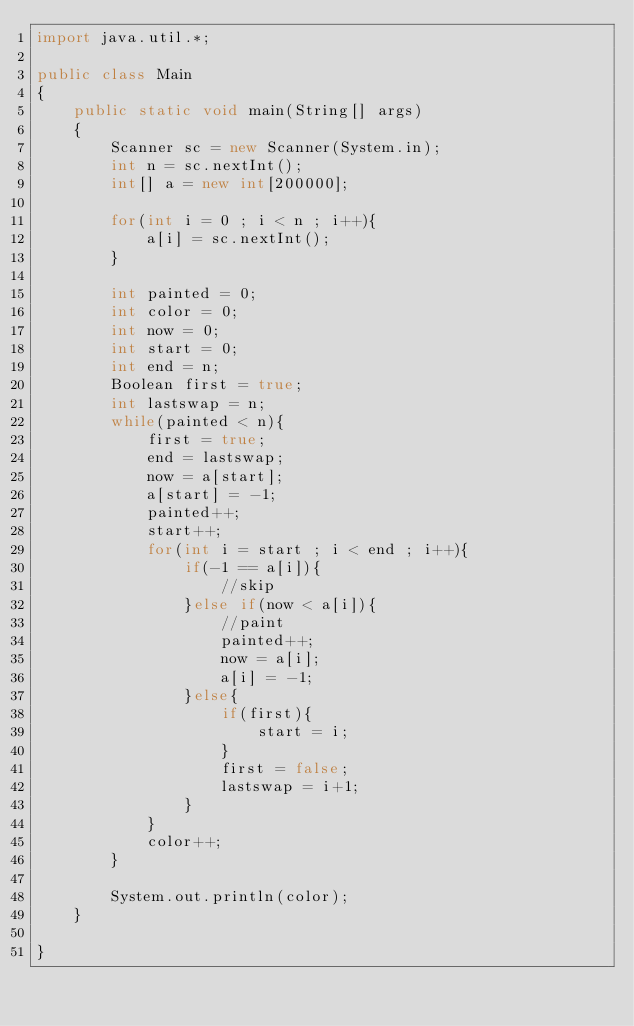<code> <loc_0><loc_0><loc_500><loc_500><_Java_>import java.util.*;

public class Main
{
	public static void main(String[] args)
	{
		Scanner sc = new Scanner(System.in);
		int n = sc.nextInt();
		int[] a = new int[200000];

		for(int i = 0 ; i < n ; i++){
			a[i] = sc.nextInt();
		}

		int painted = 0;
		int color = 0;
		int now = 0;
		int start = 0;
		int end = n;
		Boolean first = true;
		int lastswap = n;
		while(painted < n){
			first = true;
			end = lastswap;
			now = a[start];
			a[start] = -1;
			painted++;
			start++;
			for(int i = start ; i < end ; i++){
				if(-1 == a[i]){
					//skip
				}else if(now < a[i]){
					//paint
					painted++;
					now = a[i];
					a[i] = -1;
				}else{
					if(first){
						start = i;
					}
					first = false;
					lastswap = i+1;
				}
			}
			color++;
		}

		System.out.println(color);
	}

}</code> 